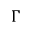<formula> <loc_0><loc_0><loc_500><loc_500>\Gamma</formula> 